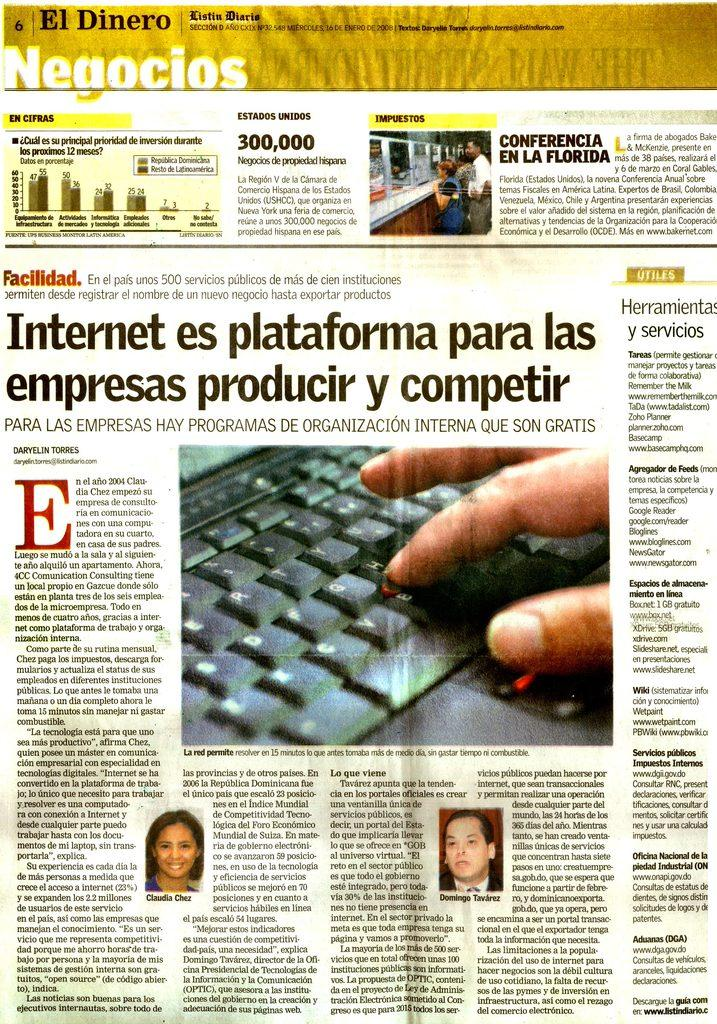What is the main subject of the picture? The main subject of the picture is a news article. What can be seen in the photos within the news article? The photos in the news article contain images of people. What is one of the objects visible on the news article? The news article includes a keyboard. Are there any other objects visible on the news article besides the keyboard? Yes, there are other objects visible on the news article. What type of content is present on the news article? The news article contains text written on it. How much meat is being used in the news article? There is no mention or depiction of meat in the news article; it is a text-based article with photos and other objects. 